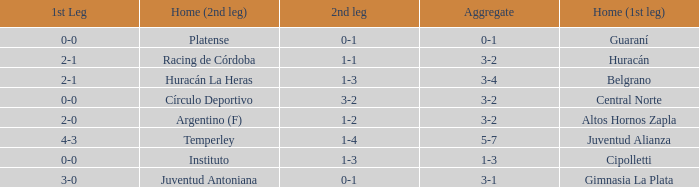What was the score of the 2nd leg when the Belgrano played the first leg at home with a score of 2-1? 1-3. 